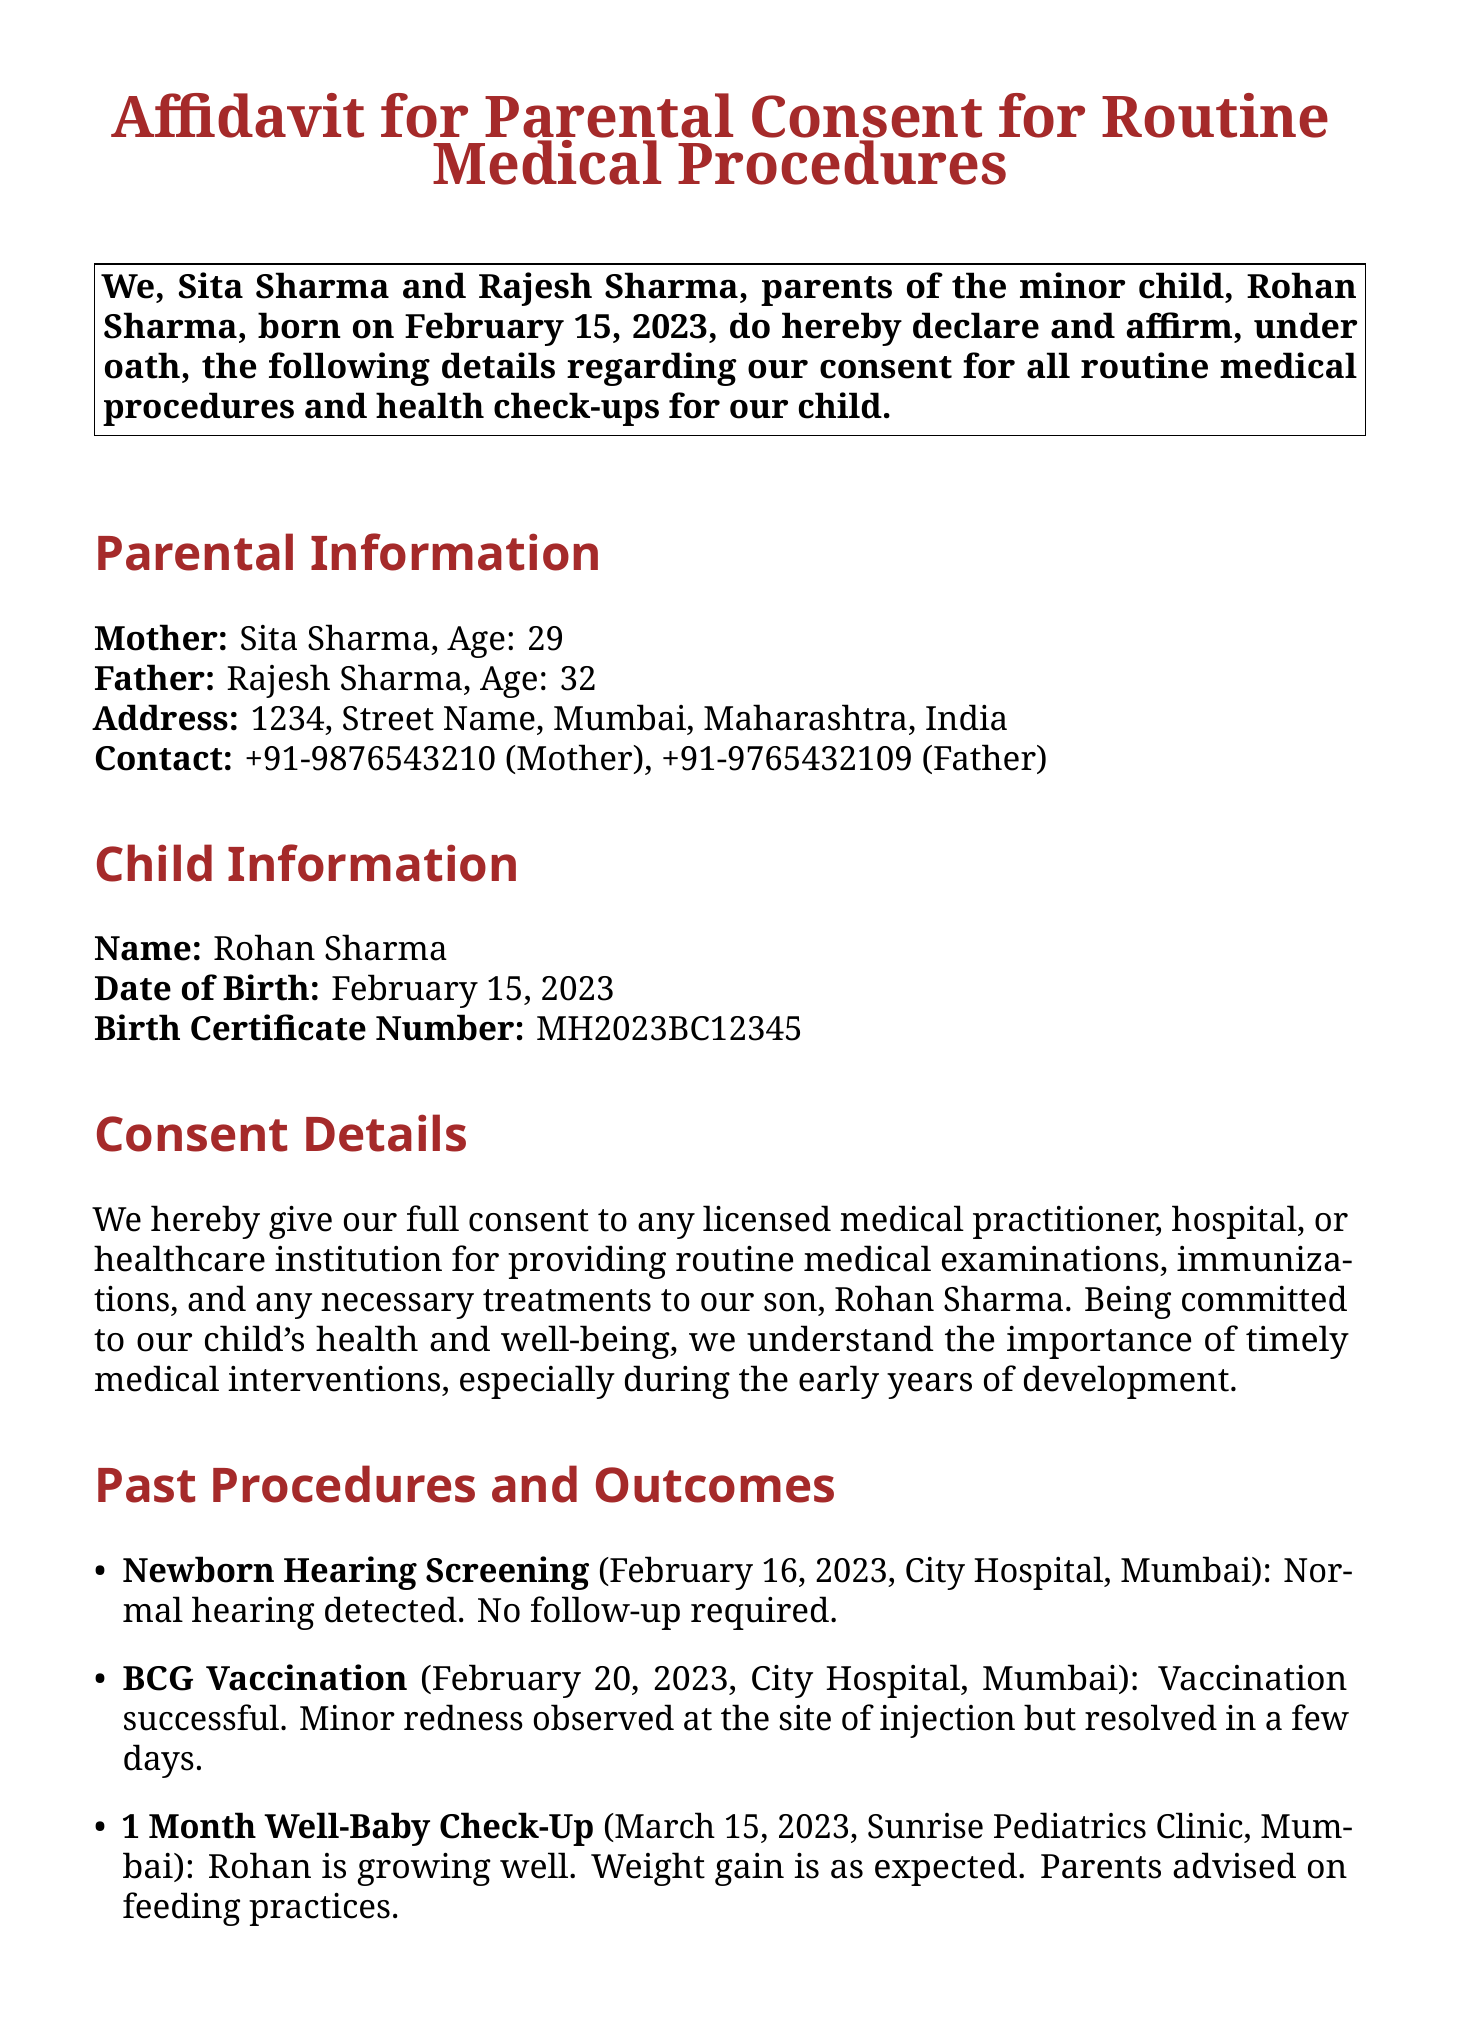What is the child's name? The child's name is clearly stated in the document under Child Information.
Answer: Rohan Sharma What is the date of birth of the child? The date of birth can be found in the Child Information section.
Answer: February 15, 2023 Who are the parents listed in the affidavit? The parents' names are listed at the beginning of the affidavit.
Answer: Sita Sharma and Rajesh Sharma What procedure was performed on February 20, 2023? The document lists procedures and their dates under Past Procedures and Outcomes.
Answer: BCG Vaccination What was the outcome of the Newborn Hearing Screening? The outcome of this procedure is mentioned in the Past Procedures and Outcomes section.
Answer: Normal hearing detected What is the contact number for the mother? The contact number for the mother is listed under Parental Information.
Answer: +91-9876543210 What type of consent is given in this affidavit? The nature of consent can be inferred from the Consent Details section of the document.
Answer: Full consent for routine medical procedures What minor issue was noted after the BCG vaccination? The document specifies any follow-up issues that arose after the vaccination.
Answer: Minor redness observed 